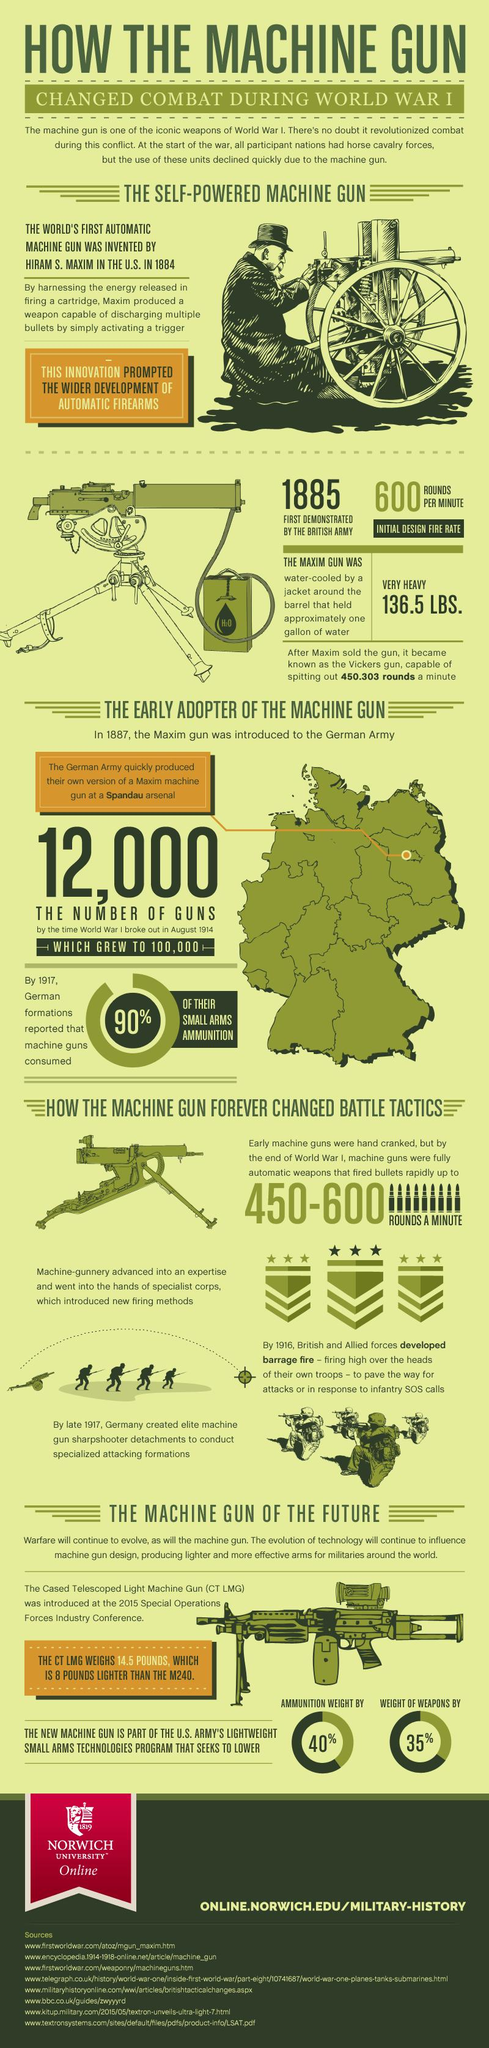Highlight a few significant elements in this photo. Eight sources are listed at the bottom. 